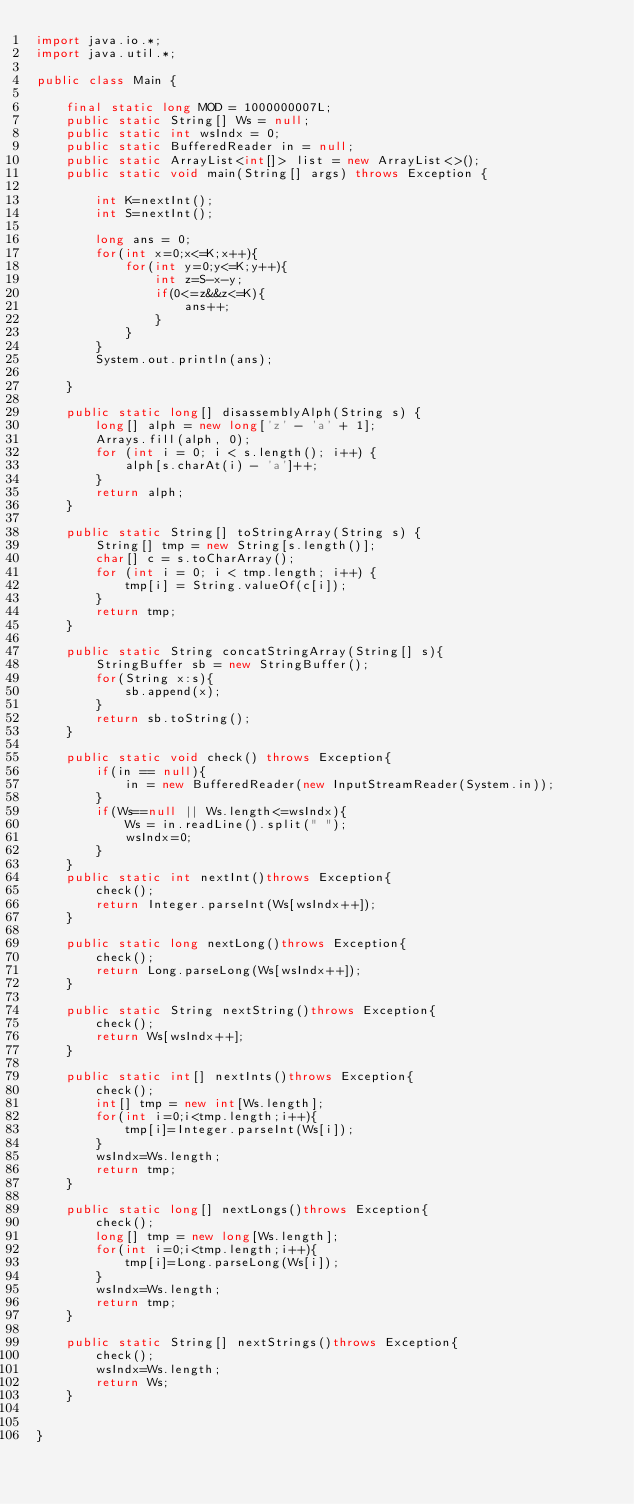Convert code to text. <code><loc_0><loc_0><loc_500><loc_500><_Java_>import java.io.*;
import java.util.*;

public class Main {

	final static long MOD = 1000000007L;
	public static String[] Ws = null;
	public static int wsIndx = 0;
	public static BufferedReader in = null;
	public static ArrayList<int[]> list = new ArrayList<>();
	public static void main(String[] args) throws Exception {

		int K=nextInt();
		int S=nextInt();

		long ans = 0;
		for(int x=0;x<=K;x++){
			for(int y=0;y<=K;y++){
				int z=S-x-y;
				if(0<=z&&z<=K){
					ans++;
				}
			}
		}
		System.out.println(ans);

	}

	public static long[] disassemblyAlph(String s) {
		long[] alph = new long['z' - 'a' + 1];
		Arrays.fill(alph, 0);
		for (int i = 0; i < s.length(); i++) {
			alph[s.charAt(i) - 'a']++;
		}
		return alph;
	}

	public static String[] toStringArray(String s) {
		String[] tmp = new String[s.length()];
		char[] c = s.toCharArray();
		for (int i = 0; i < tmp.length; i++) {
			tmp[i] = String.valueOf(c[i]);
		}
		return tmp;
	}

	public static String concatStringArray(String[] s){
		StringBuffer sb = new StringBuffer();
		for(String x:s){
			sb.append(x);
		}
		return sb.toString();
	}

	public static void check() throws Exception{
		if(in == null){
			in = new BufferedReader(new InputStreamReader(System.in));
		}
		if(Ws==null || Ws.length<=wsIndx){
			Ws = in.readLine().split(" ");
			wsIndx=0;
		}
	}
	public static int nextInt()throws Exception{
		check();
		return Integer.parseInt(Ws[wsIndx++]);
	}

	public static long nextLong()throws Exception{
		check();
		return Long.parseLong(Ws[wsIndx++]);
	}

	public static String nextString()throws Exception{
		check();
		return Ws[wsIndx++];
	}

	public static int[] nextInts()throws Exception{
		check();
		int[] tmp = new int[Ws.length];
		for(int i=0;i<tmp.length;i++){
			tmp[i]=Integer.parseInt(Ws[i]);
		}
		wsIndx=Ws.length;
		return tmp;
	}

	public static long[] nextLongs()throws Exception{
		check();
		long[] tmp = new long[Ws.length];
		for(int i=0;i<tmp.length;i++){
			tmp[i]=Long.parseLong(Ws[i]);
		}
		wsIndx=Ws.length;
		return tmp;
	}

	public static String[] nextStrings()throws Exception{
		check();
		wsIndx=Ws.length;
		return Ws;
	}


}</code> 